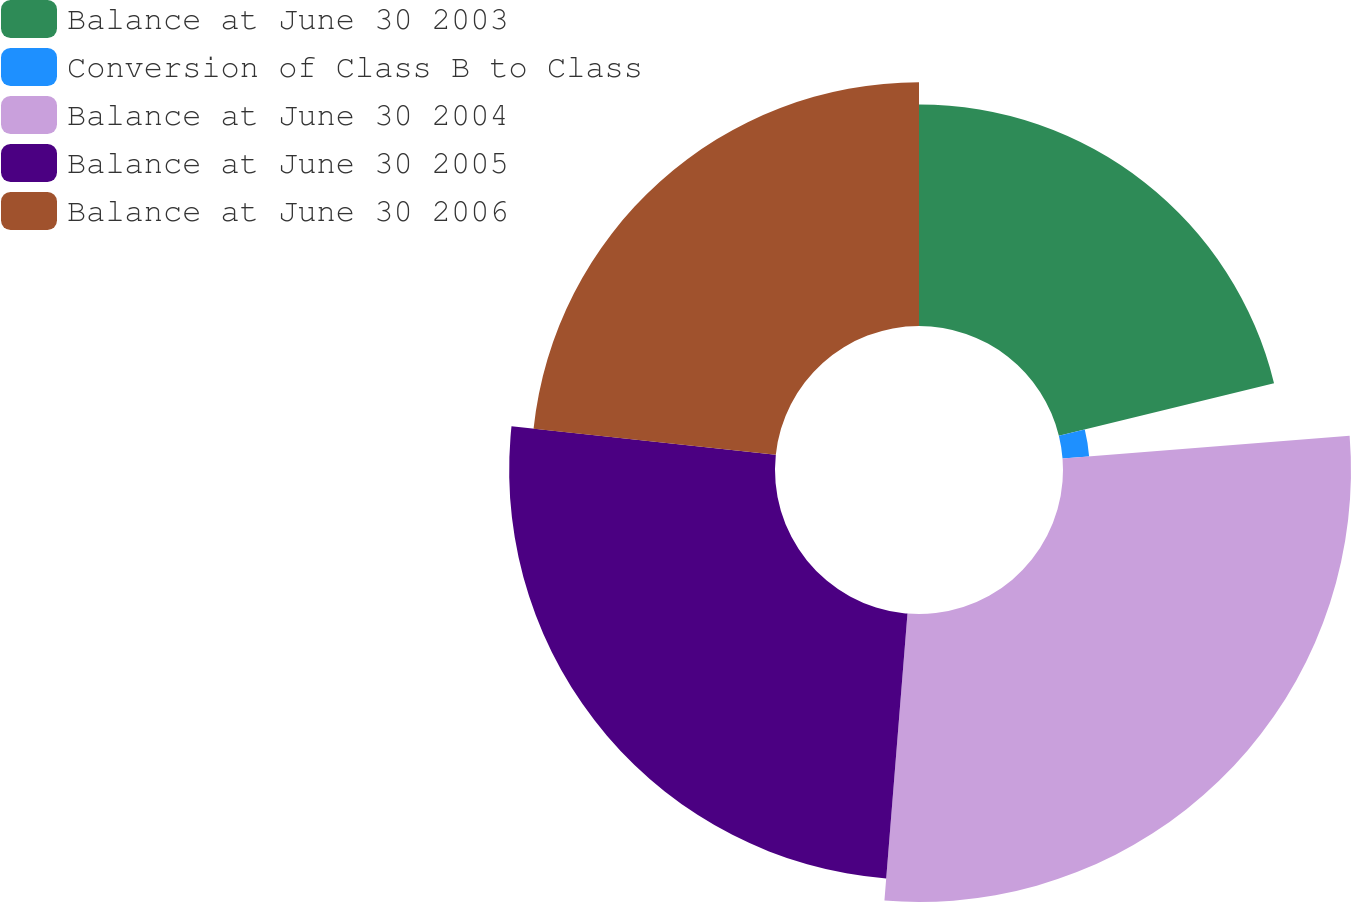Convert chart to OTSL. <chart><loc_0><loc_0><loc_500><loc_500><pie_chart><fcel>Balance at June 30 2003<fcel>Conversion of Class B to Class<fcel>Balance at June 30 2004<fcel>Balance at June 30 2005<fcel>Balance at June 30 2006<nl><fcel>21.18%<fcel>2.55%<fcel>27.54%<fcel>25.42%<fcel>23.3%<nl></chart> 